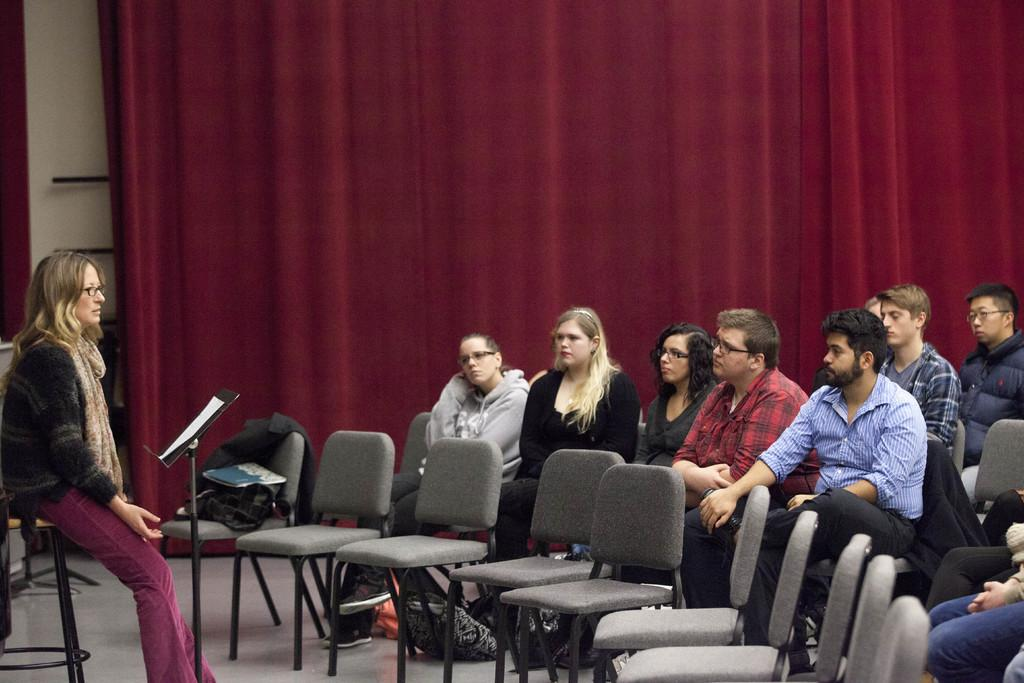What is happening in the image involving a group of people? In the image, there is a group of people sitting on chairs. What is the purpose of the paper on a stand? The purpose of the paper on a stand is not clear from the image, but it could be a presentation or an announcement. What can be seen in the background of the image? In the background of the image, there are curtains. What type of powder is being used by the people in the image? There is no powder visible in the image, and it is not mentioned in the provided facts. 